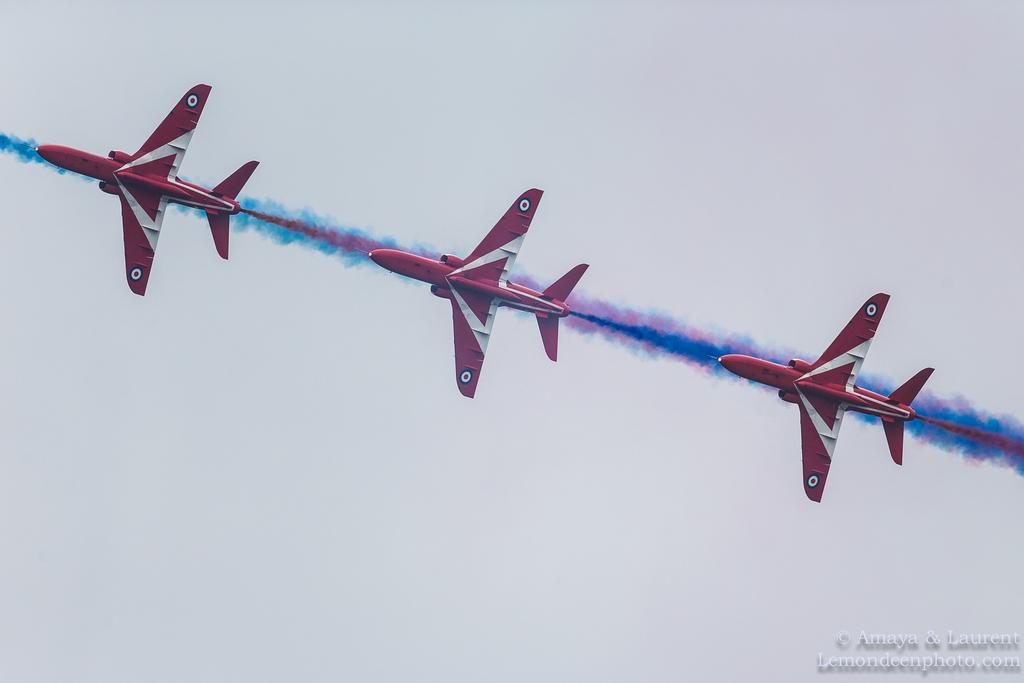What is the main subject of the image? The main subject of the image is three jet planes. What are the jet planes doing in the image? The jet planes are flying in the air. What can be seen in the background of the image? The sky is visible in the background of the image. Is there any text present in the image? Yes, there is some text at the right bottom of the image. Can you tell me how many dolls are sitting next to the yak in the image? There are no dolls or yaks present in the image; it features three jet planes flying in the air. 